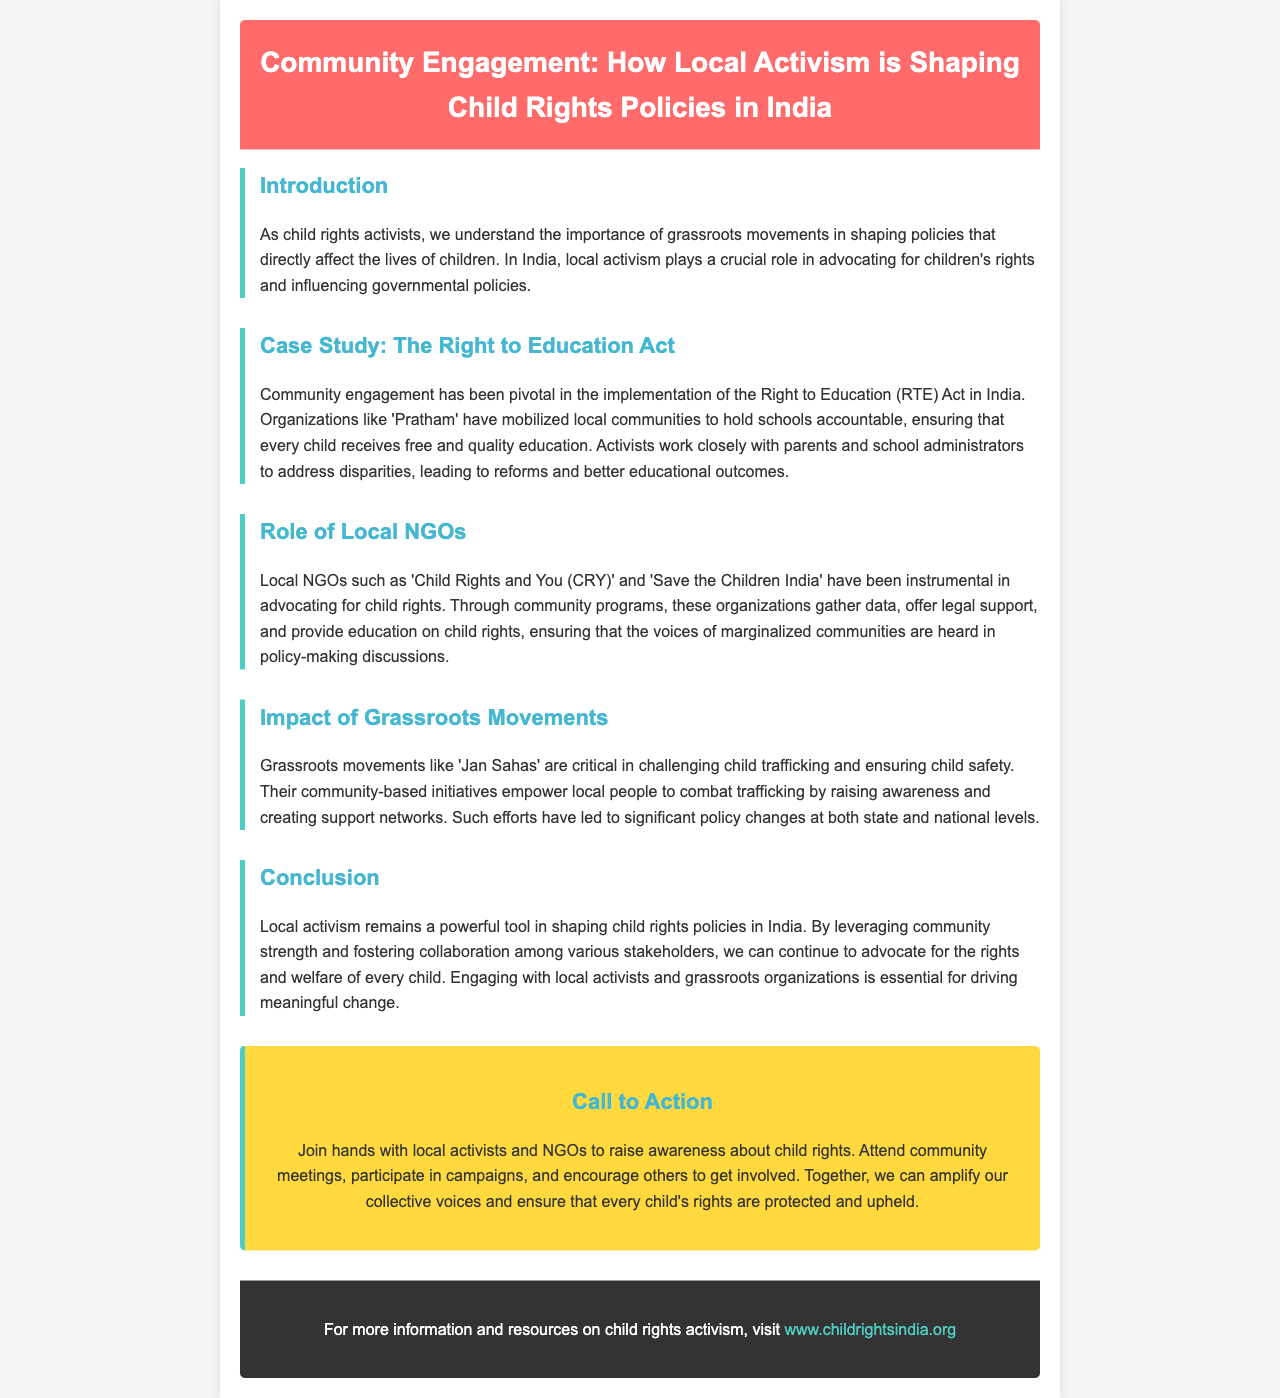What is the main focus of the newsletter? The main focus of the newsletter is on local activism and its impact on child rights policies in India.
Answer: local activism and child rights policies in India Which act is highlighted as a case study in the document? The case study highlighted is the Right to Education Act.
Answer: Right to Education Act Who is one of the organizations mentioned that mobilizes local communities for education? The organization mentioned that mobilizes local communities is 'Pratham'.
Answer: Pratham What type of organizations are mentioned to advocate for child rights? Local NGOs are mentioned as organizations that advocate for child rights.
Answer: Local NGOs What grassroots movement is noted for combating child trafficking? The grassroots movement noted for combating child trafficking is 'Jan Sahas'.
Answer: Jan Sahas How can people join in local child rights activism according to the call to action? People can join by attending community meetings and participating in campaigns.
Answer: community meetings and campaigns Which organization's website is provided for more child rights resources? The website provided for more resources is for 'Child Rights India'.
Answer: Child Rights India What is the significance of community engagement mentioned in the newsletter? Community engagement is significant for holding schools accountable and ensuring rights are upheld.
Answer: holding schools accountable and ensuring rights are upheld Who are the primary stakeholders involved in advocating for child rights as per the document? The primary stakeholders include local activists and NGOs.
Answer: local activists and NGOs 